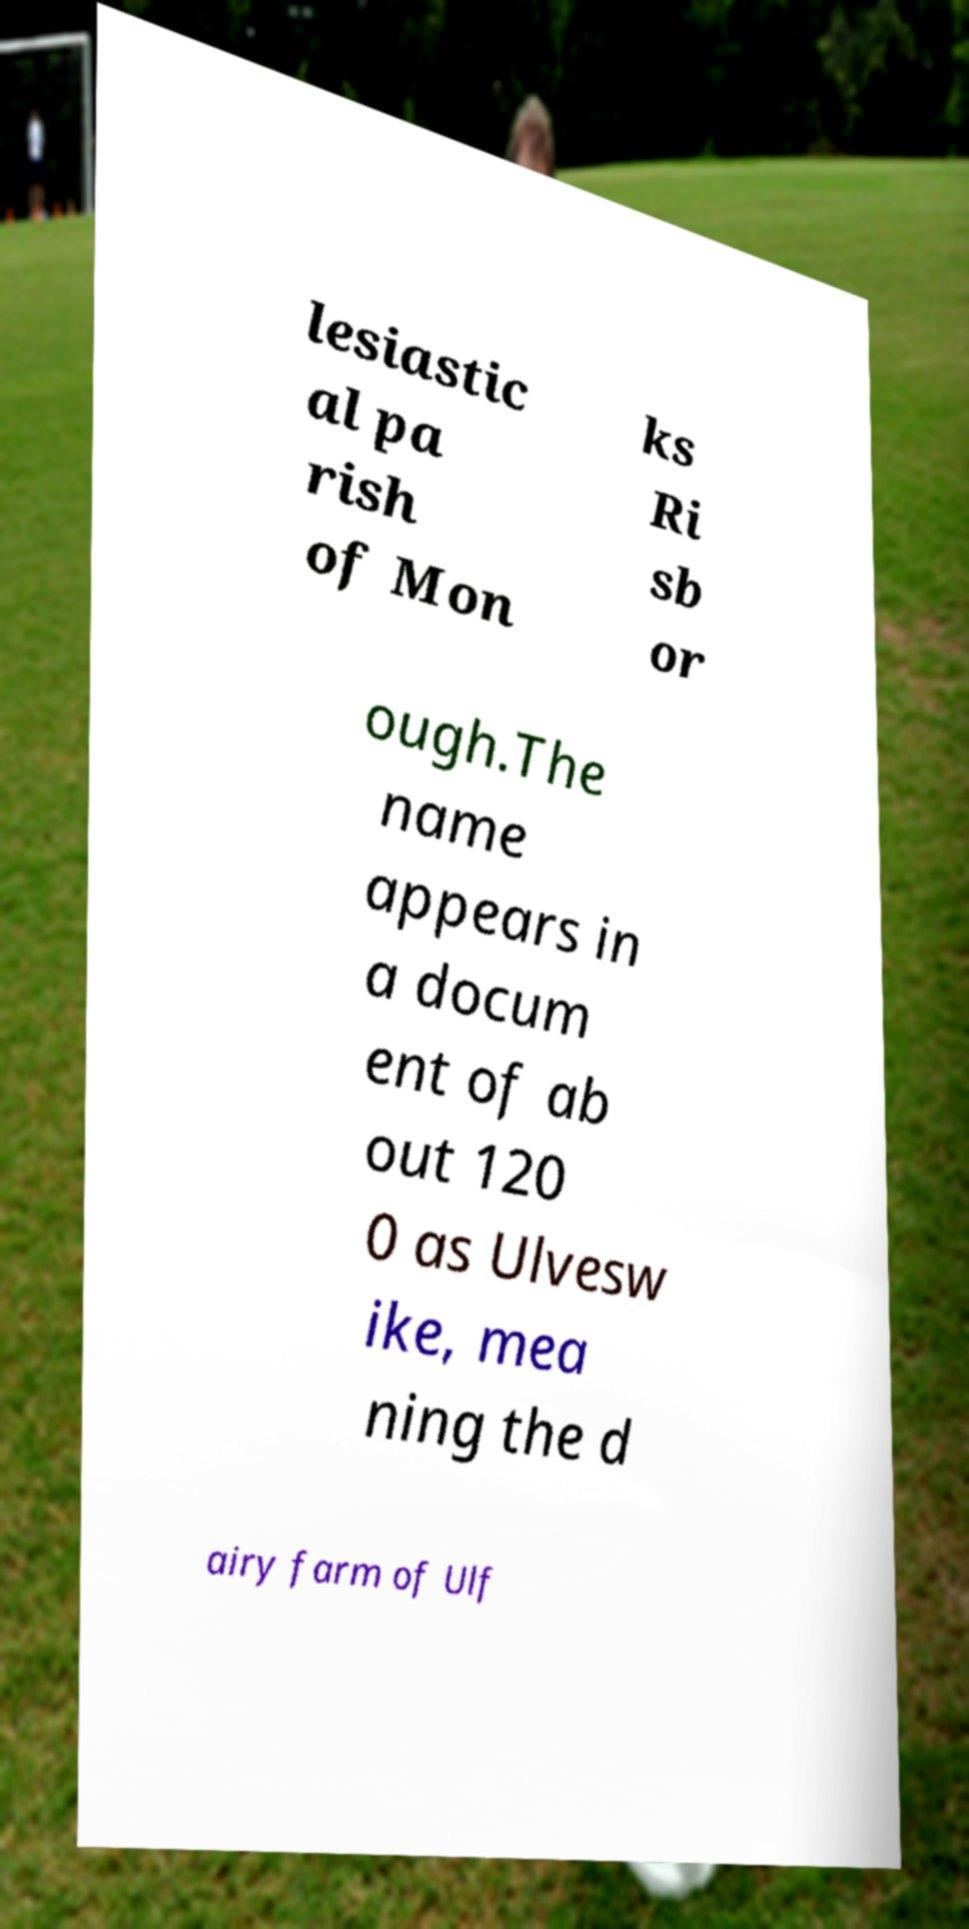For documentation purposes, I need the text within this image transcribed. Could you provide that? lesiastic al pa rish of Mon ks Ri sb or ough.The name appears in a docum ent of ab out 120 0 as Ulvesw ike, mea ning the d airy farm of Ulf 